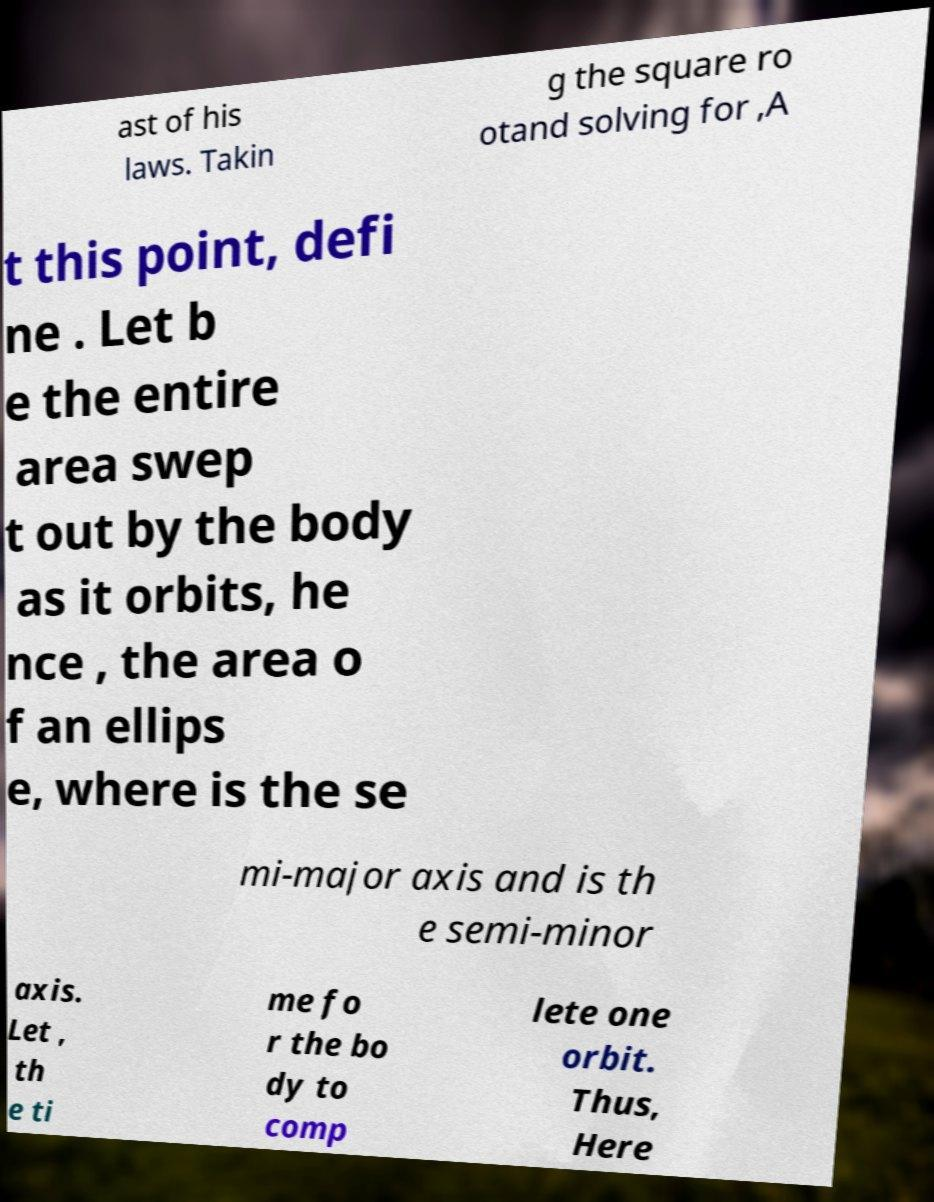There's text embedded in this image that I need extracted. Can you transcribe it verbatim? ast of his laws. Takin g the square ro otand solving for ,A t this point, defi ne . Let b e the entire area swep t out by the body as it orbits, he nce , the area o f an ellips e, where is the se mi-major axis and is th e semi-minor axis. Let , th e ti me fo r the bo dy to comp lete one orbit. Thus, Here 